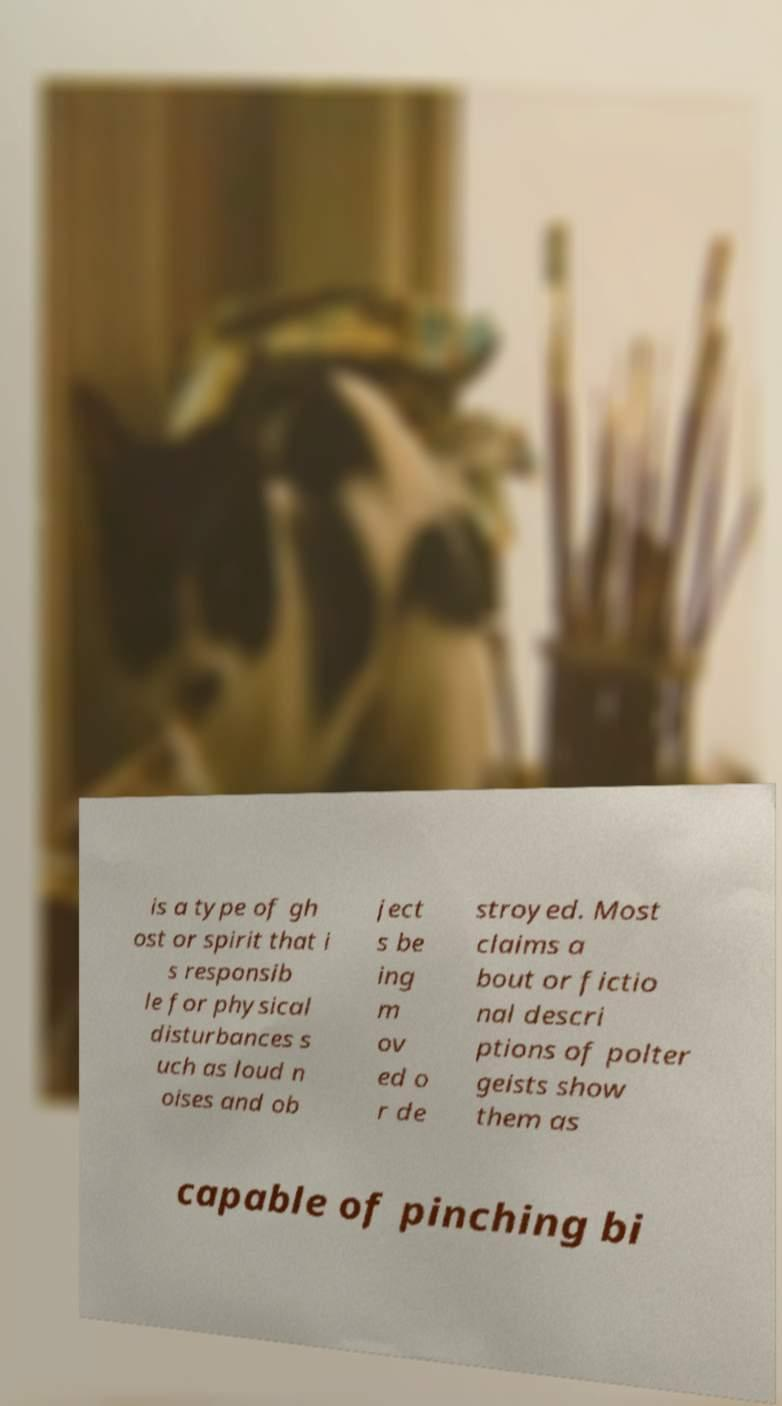I need the written content from this picture converted into text. Can you do that? is a type of gh ost or spirit that i s responsib le for physical disturbances s uch as loud n oises and ob ject s be ing m ov ed o r de stroyed. Most claims a bout or fictio nal descri ptions of polter geists show them as capable of pinching bi 